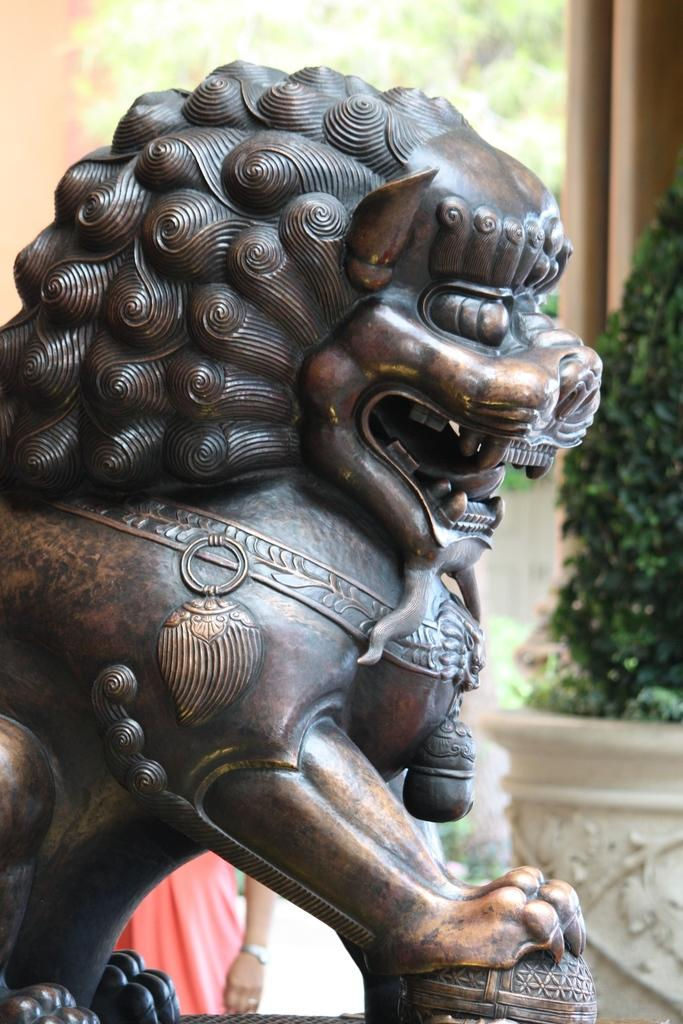What is the main subject of the sculpture in the image? There is a sculpture of a lion in the image. Can you describe the person standing behind the sculpture? There is a person standing behind the sculpture, but their appearance or actions are not specified. What architectural features can be seen in the image? There are pillars visible in the image. What type of vegetation is present in the image? There are trees and a plant in the image. What type of dolls can be seen accompanying the person on their voyage in the image? There is no mention of dolls or a voyage in the image; it features a sculpture of a lion, a person standing behind it, pillars, trees, and a plant. What type of quill is the person using to write on the sculpture in the image? There is no quill or writing activity depicted in the image; it only shows a sculpture of a lion, a person standing behind it, pillars, trees, and a plant. 